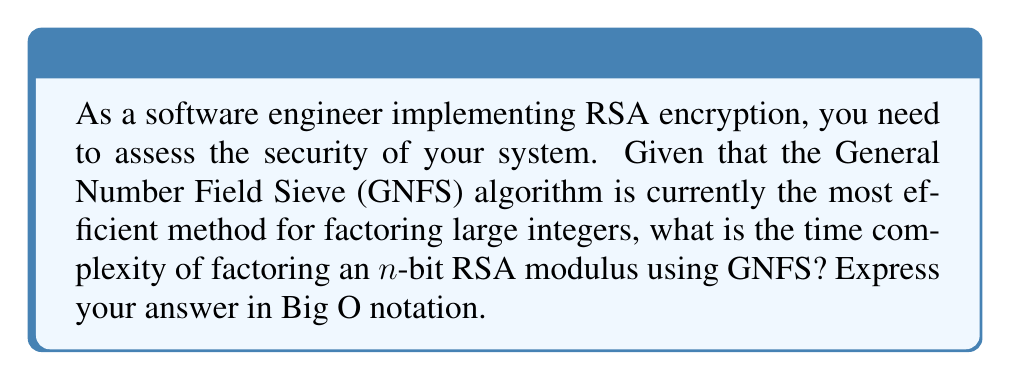What is the answer to this math problem? To determine the time complexity of factoring large prime numbers for RSA encryption using the General Number Field Sieve (GNFS) algorithm, we need to follow these steps:

1. Understand the GNFS algorithm:
   The GNFS is the most efficient known algorithm for factoring large integers, which is crucial for breaking RSA encryption.

2. Analyze the complexity of GNFS:
   The time complexity of GNFS is sub-exponential in the number of bits of the integer to be factored.

3. Express the complexity formula:
   The time complexity of GNFS for factoring an n-bit integer is:

   $$O(e^{(\sqrt[3]{\frac{64}{9}}+o(1))(\ln n)^{\frac{1}{3}}(\ln \ln n)^{\frac{2}{3}}})$$

4. Simplify the notation:
   For practical purposes and easier implementation considerations, this complexity is often approximated as:

   $$O(L_n[\frac{1}{3}, \sqrt[3]{\frac{64}{9}}])$$

   Where $L_n[a,b]$ is the L-notation defined as:

   $$L_n[a,b] = e^{(b+o(1))(\ln n)^a(\ln \ln n)^{1-a}}$$

5. Interpret the result:
   This sub-exponential time complexity is significantly faster than naive factoring methods, but still slow enough to make RSA secure when sufficiently large key sizes are used.

As a software engineer, understanding this complexity helps in choosing appropriate key sizes and assessing the security of the RSA implementation against potential factoring attacks.
Answer: $O(L_n[\frac{1}{3}, \sqrt[3]{\frac{64}{9}}])$ 